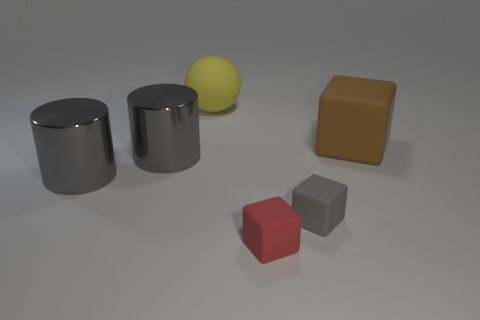Subtract all tiny gray blocks. How many blocks are left? 2 Subtract all brown blocks. How many blocks are left? 2 Subtract all cylinders. How many objects are left? 4 Add 4 yellow matte spheres. How many objects exist? 10 Subtract 1 cubes. How many cubes are left? 2 Subtract all green balls. How many red cylinders are left? 0 Subtract 0 gray balls. How many objects are left? 6 Subtract all red balls. Subtract all cyan cubes. How many balls are left? 1 Subtract all tiny blue matte balls. Subtract all rubber blocks. How many objects are left? 3 Add 5 red things. How many red things are left? 6 